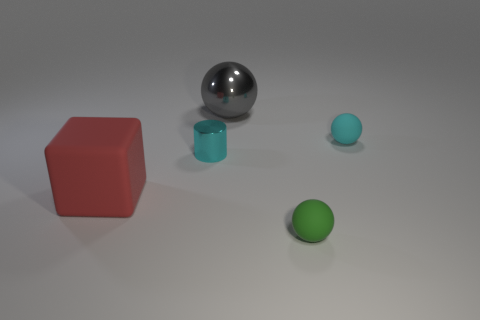Are there any balls in front of the tiny cyan rubber object?
Your answer should be very brief. Yes. What number of big cubes are there?
Your response must be concise. 1. There is a big gray object to the right of the large red rubber object; how many tiny rubber things are on the right side of it?
Offer a very short reply. 2. There is a tiny metallic cylinder; is its color the same as the tiny matte ball that is behind the large red cube?
Ensure brevity in your answer.  Yes. What number of large gray things have the same shape as the cyan rubber thing?
Offer a very short reply. 1. What is the ball that is to the left of the small green matte sphere made of?
Offer a terse response. Metal. There is a big thing that is right of the metallic cylinder; is it the same shape as the large red rubber thing?
Provide a short and direct response. No. Is there a yellow shiny cylinder of the same size as the cyan matte thing?
Offer a terse response. No. There is a big red rubber thing; does it have the same shape as the small cyan thing that is to the left of the large sphere?
Offer a terse response. No. The thing that is the same color as the small metallic cylinder is what shape?
Your answer should be very brief. Sphere. 